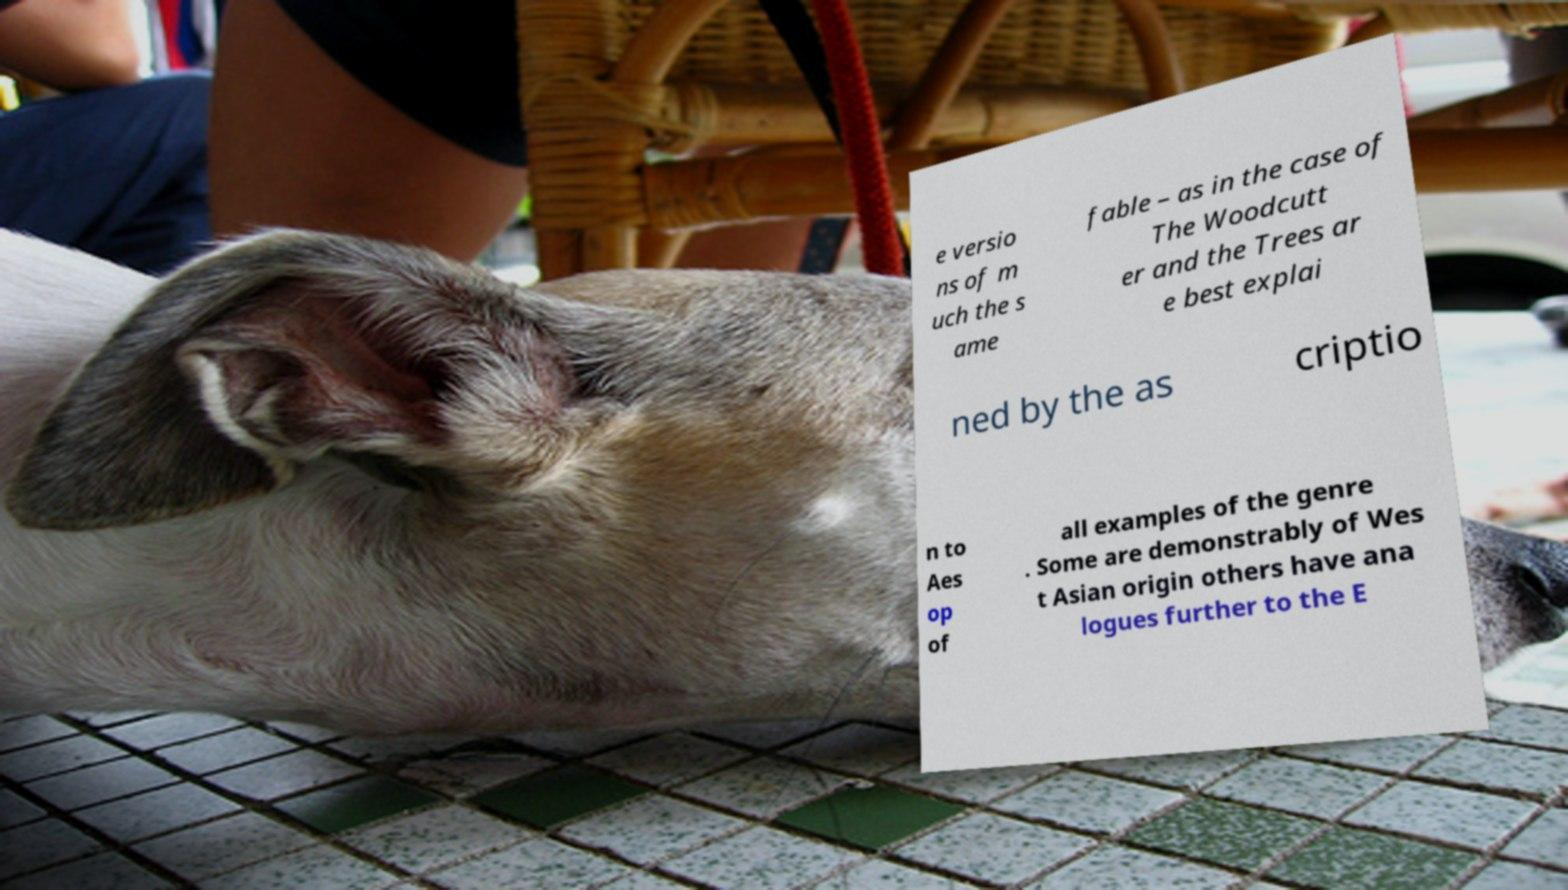Please read and relay the text visible in this image. What does it say? e versio ns of m uch the s ame fable – as in the case of The Woodcutt er and the Trees ar e best explai ned by the as criptio n to Aes op of all examples of the genre . Some are demonstrably of Wes t Asian origin others have ana logues further to the E 